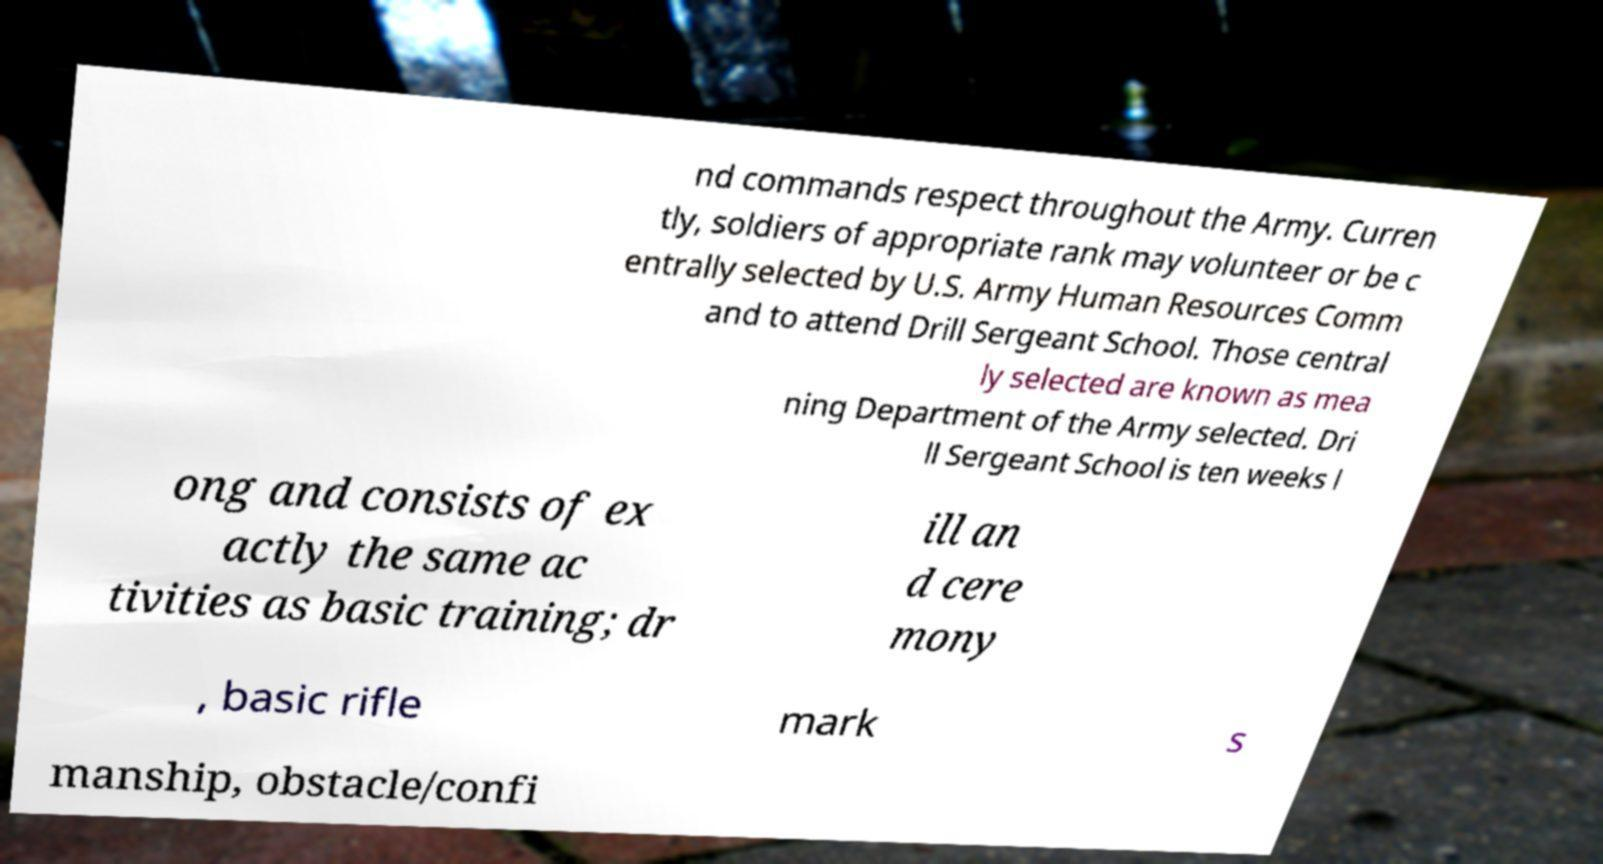Please identify and transcribe the text found in this image. nd commands respect throughout the Army. Curren tly, soldiers of appropriate rank may volunteer or be c entrally selected by U.S. Army Human Resources Comm and to attend Drill Sergeant School. Those central ly selected are known as mea ning Department of the Army selected. Dri ll Sergeant School is ten weeks l ong and consists of ex actly the same ac tivities as basic training; dr ill an d cere mony , basic rifle mark s manship, obstacle/confi 